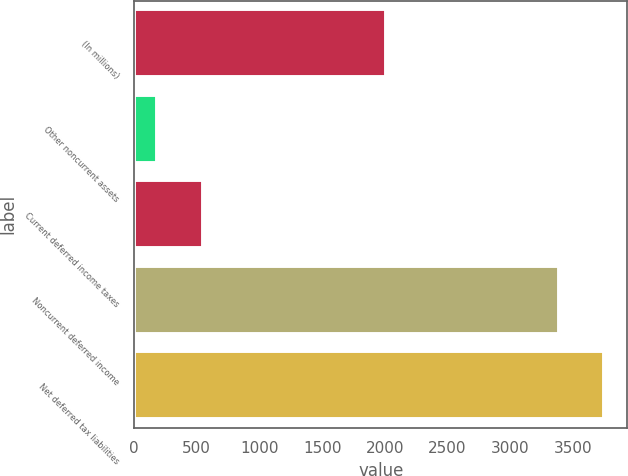<chart> <loc_0><loc_0><loc_500><loc_500><bar_chart><fcel>(In millions)<fcel>Other noncurrent assets<fcel>Current deferred income taxes<fcel>Noncurrent deferred income<fcel>Net deferred tax liabilities<nl><fcel>2007<fcel>185<fcel>547<fcel>3389<fcel>3749<nl></chart> 